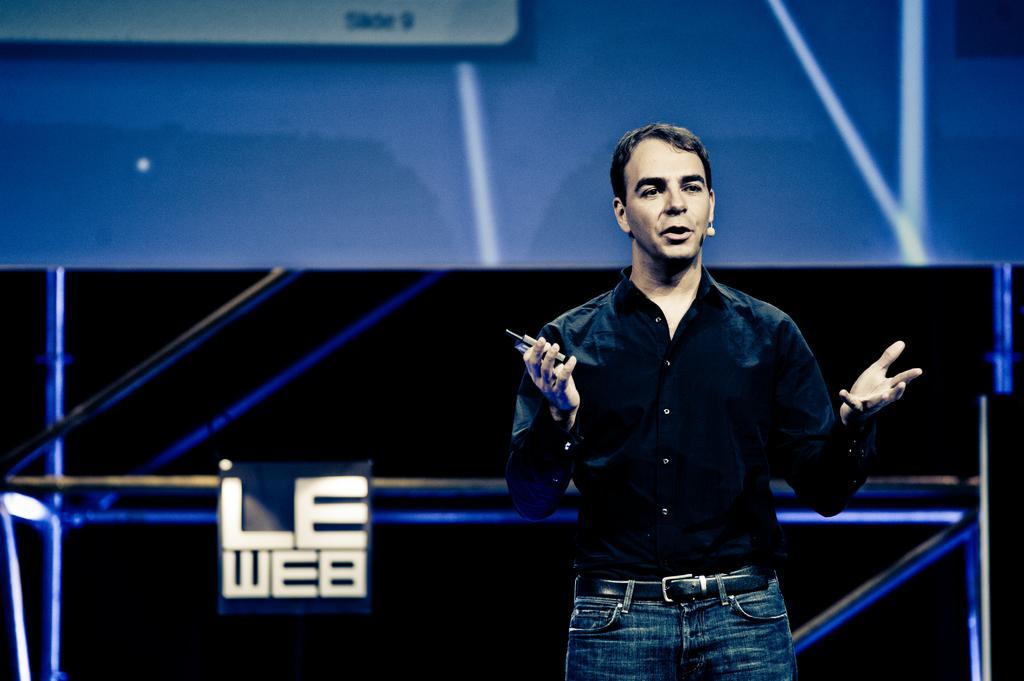Could you give a brief overview of what you see in this image? In this picture we can see a man holding an object with his hand and in the background we can see the wall, some objects. 